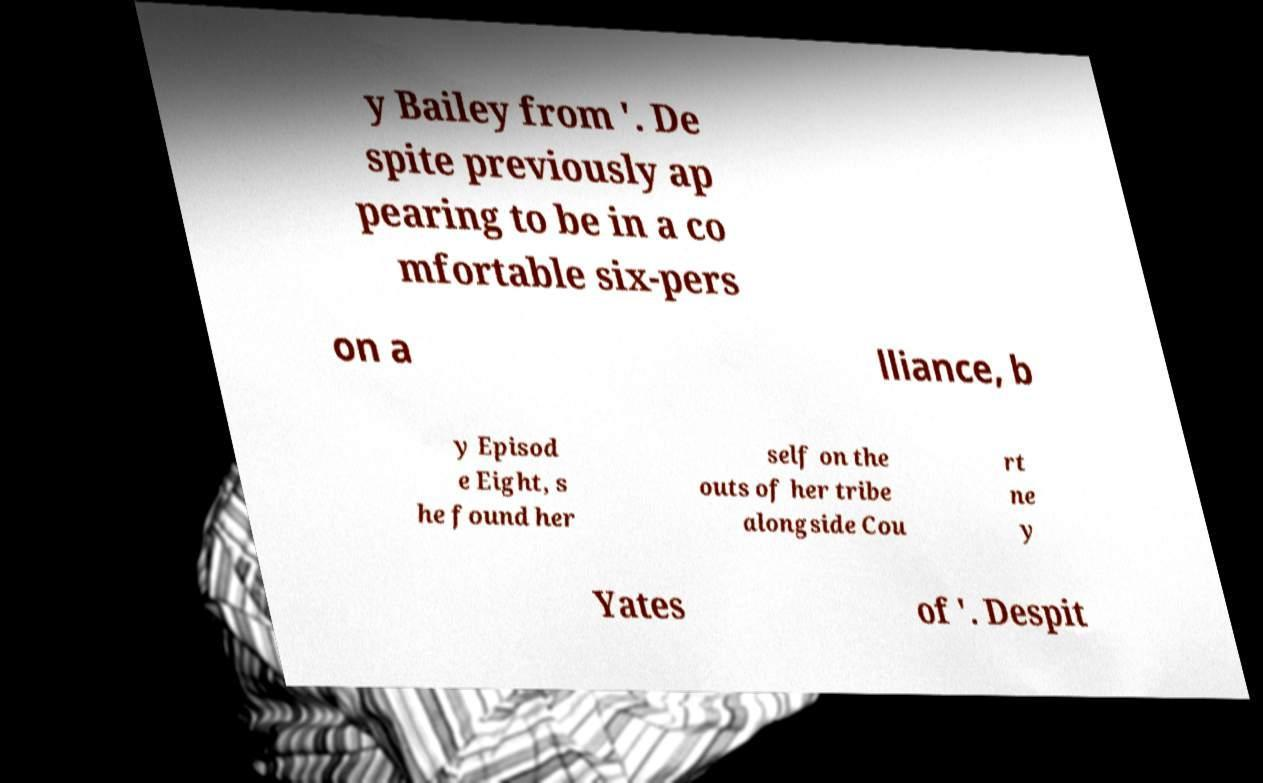Could you extract and type out the text from this image? y Bailey from '. De spite previously ap pearing to be in a co mfortable six-pers on a lliance, b y Episod e Eight, s he found her self on the outs of her tribe alongside Cou rt ne y Yates of '. Despit 